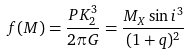<formula> <loc_0><loc_0><loc_500><loc_500>f ( M ) = \frac { P K _ { 2 } ^ { 3 } } { 2 \pi G } = \frac { M _ { X } \sin { i } ^ { 3 } } { ( 1 + q ) ^ { 2 } }</formula> 